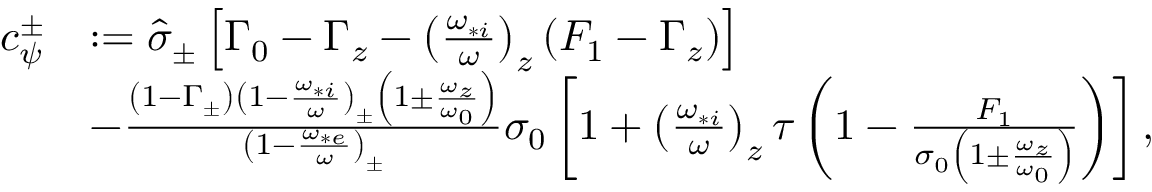Convert formula to latex. <formula><loc_0><loc_0><loc_500><loc_500>\begin{array} { r l } { c _ { \psi } ^ { \pm } } & { \colon = \hat { \sigma } _ { \pm } \left [ \Gamma _ { 0 } - \Gamma _ { z } - \left ( \frac { \omega _ { * i } } { \omega } \right ) _ { z } \left ( F _ { 1 } - \Gamma _ { z } \right ) \right ] } \\ & { - \frac { \left ( 1 - \Gamma _ { \pm } \right ) \left ( 1 - \frac { \omega _ { * i } } { \omega } \right ) _ { \pm } \left ( 1 \pm \frac { \omega _ { z } } { \omega _ { 0 } } \right ) } { \left ( 1 - \frac { \omega _ { * e } } { \omega } \right ) _ { \pm } } \sigma _ { 0 } \left [ 1 + \left ( \frac { \omega _ { * i } } { \omega } \right ) _ { z } \tau \left ( 1 - \frac { F _ { 1 } } { \sigma _ { 0 } \left ( 1 \pm \frac { \omega _ { z } } { \omega _ { 0 } } \right ) } \right ) \right ] , } \end{array}</formula> 